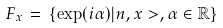Convert formula to latex. <formula><loc_0><loc_0><loc_500><loc_500>F _ { x } \, = \, \{ \exp ( i \alpha ) | { n } , x > , \alpha \in { \mathbb { R } } \}</formula> 